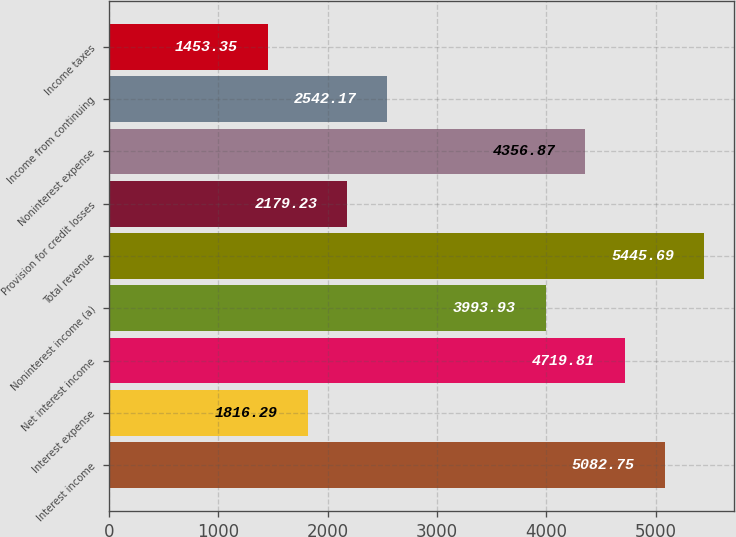<chart> <loc_0><loc_0><loc_500><loc_500><bar_chart><fcel>Interest income<fcel>Interest expense<fcel>Net interest income<fcel>Noninterest income (a)<fcel>Total revenue<fcel>Provision for credit losses<fcel>Noninterest expense<fcel>Income from continuing<fcel>Income taxes<nl><fcel>5082.75<fcel>1816.29<fcel>4719.81<fcel>3993.93<fcel>5445.69<fcel>2179.23<fcel>4356.87<fcel>2542.17<fcel>1453.35<nl></chart> 